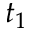Convert formula to latex. <formula><loc_0><loc_0><loc_500><loc_500>t _ { 1 }</formula> 